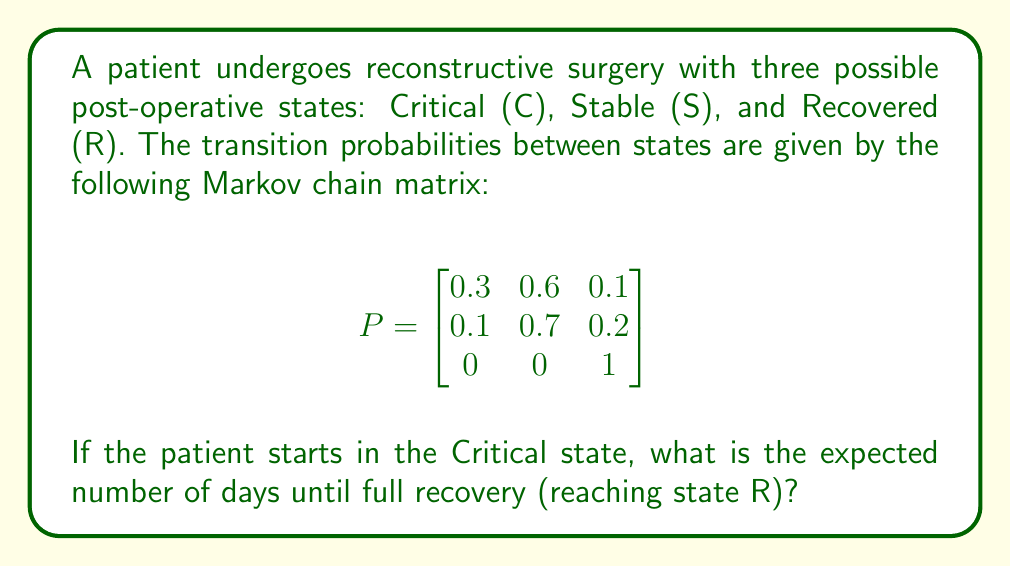Give your solution to this math problem. To solve this problem, we'll use the concept of absorbing Markov chains and fundamental matrix.

Step 1: Identify the absorbing state (R) and transient states (C and S).

Step 2: Rewrite the transition matrix in canonical form:
$$P = \begin{bmatrix}
Q & R \\
0 & I
\end{bmatrix}$$

Where:
$$Q = \begin{bmatrix}
0.3 & 0.6 \\
0.1 & 0.7
\end{bmatrix}$$

Step 3: Calculate the fundamental matrix $N = (I-Q)^{-1}$

$$I-Q = \begin{bmatrix}
1 & 0 \\
0 & 1
\end{bmatrix} - \begin{bmatrix}
0.3 & 0.6 \\
0.1 & 0.7
\end{bmatrix} = \begin{bmatrix}
0.7 & -0.6 \\
-0.1 & 0.3
\end{bmatrix}$$

$$N = (I-Q)^{-1} = \frac{1}{0.7 \cdot 0.3 - (-0.6) \cdot (-0.1)} \begin{bmatrix}
0.3 & 0.6 \\
0.1 & 0.7
\end{bmatrix} = \begin{bmatrix}
2.5 & 5 \\
0.833 & 5.833
\end{bmatrix}$$

Step 4: The expected number of steps to absorption (recovery) is the sum of the first row of $N$ (since we start in the Critical state):

$2.5 + 5 = 7.5$

Therefore, the expected number of days until full recovery is 7.5 days.
Answer: 7.5 days 